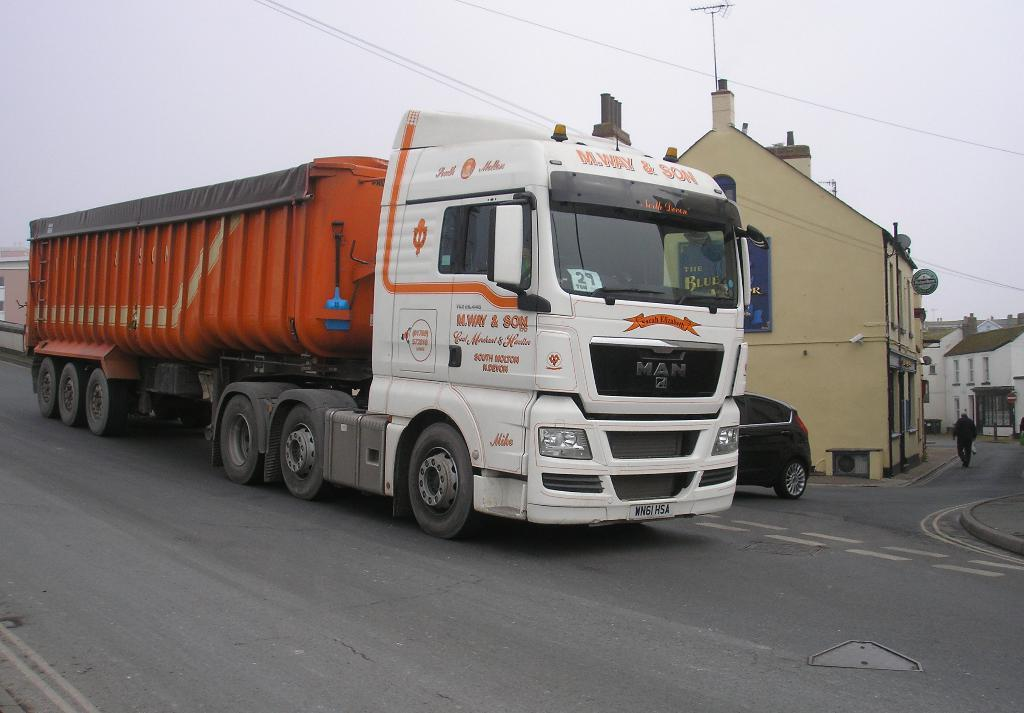What is happening on the road in the image? There are vehicles on the road in the image. What is the person in the image doing? There is a person walking in the image. What type of structures can be seen in the image? There are buildings visible in the image. What is attached to a building wall in the image? There is a board attached to a building wall in the image. What is visible in the background of the image? The sky is visible in the image. Can you see a net being used by the person walking in the image? There is no net present in the image; the person is simply walking. Is there a bomb visible in the image? There is no bomb present in the image. 